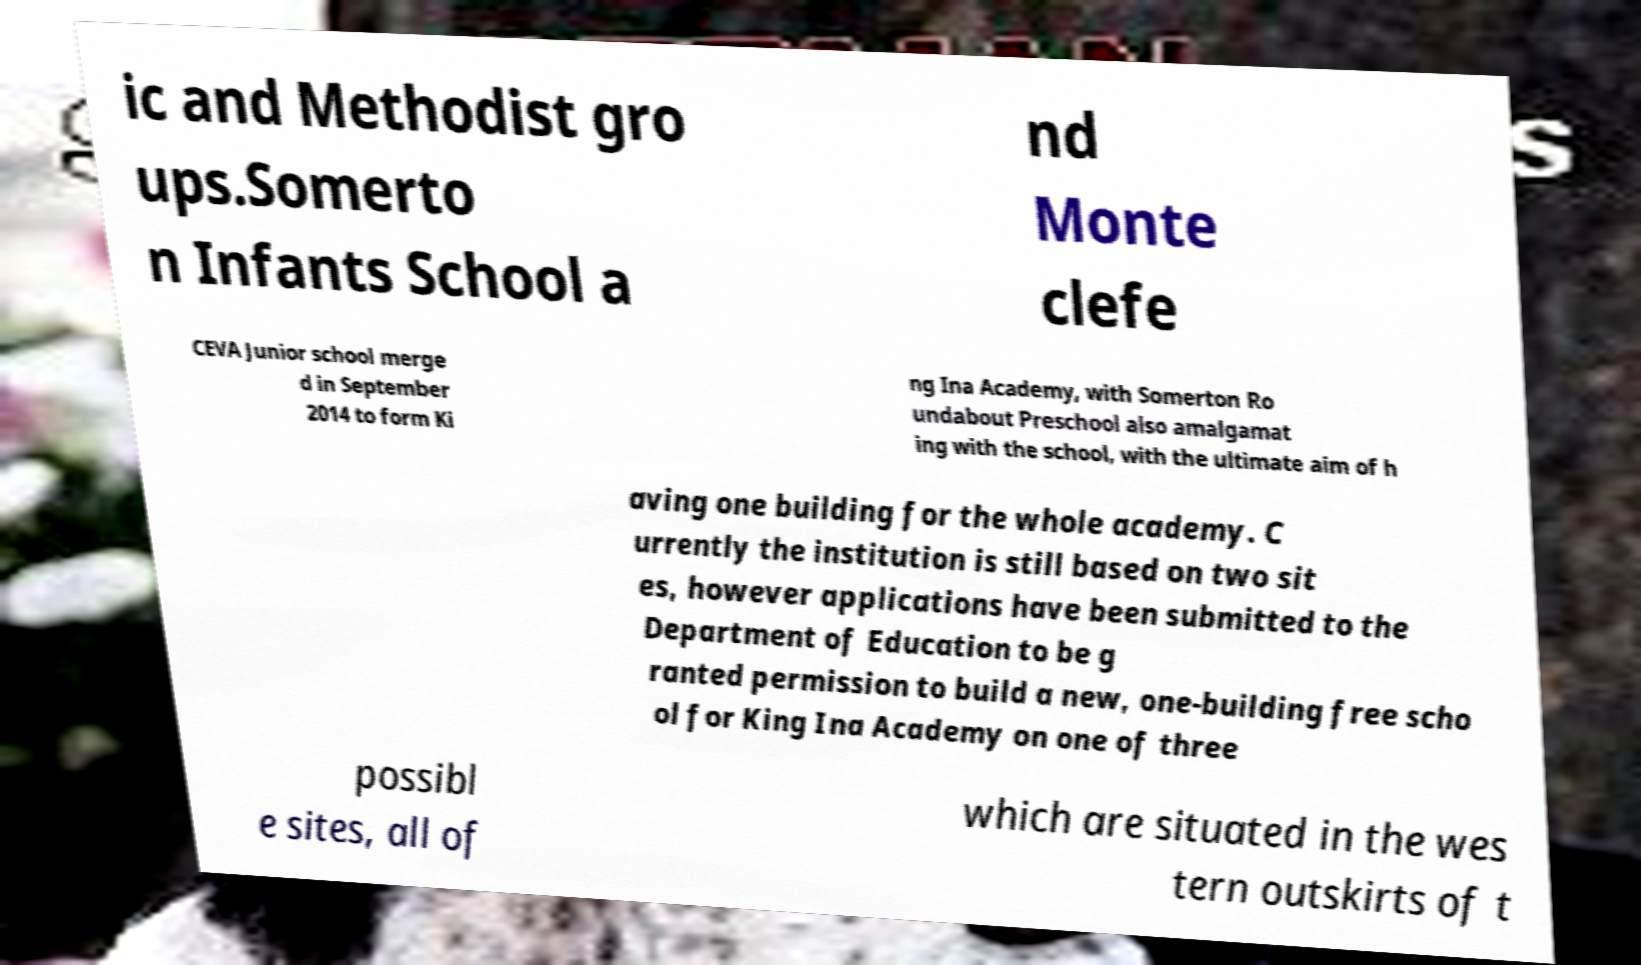What messages or text are displayed in this image? I need them in a readable, typed format. ic and Methodist gro ups.Somerto n Infants School a nd Monte clefe CEVA Junior school merge d in September 2014 to form Ki ng Ina Academy, with Somerton Ro undabout Preschool also amalgamat ing with the school, with the ultimate aim of h aving one building for the whole academy. C urrently the institution is still based on two sit es, however applications have been submitted to the Department of Education to be g ranted permission to build a new, one-building free scho ol for King Ina Academy on one of three possibl e sites, all of which are situated in the wes tern outskirts of t 